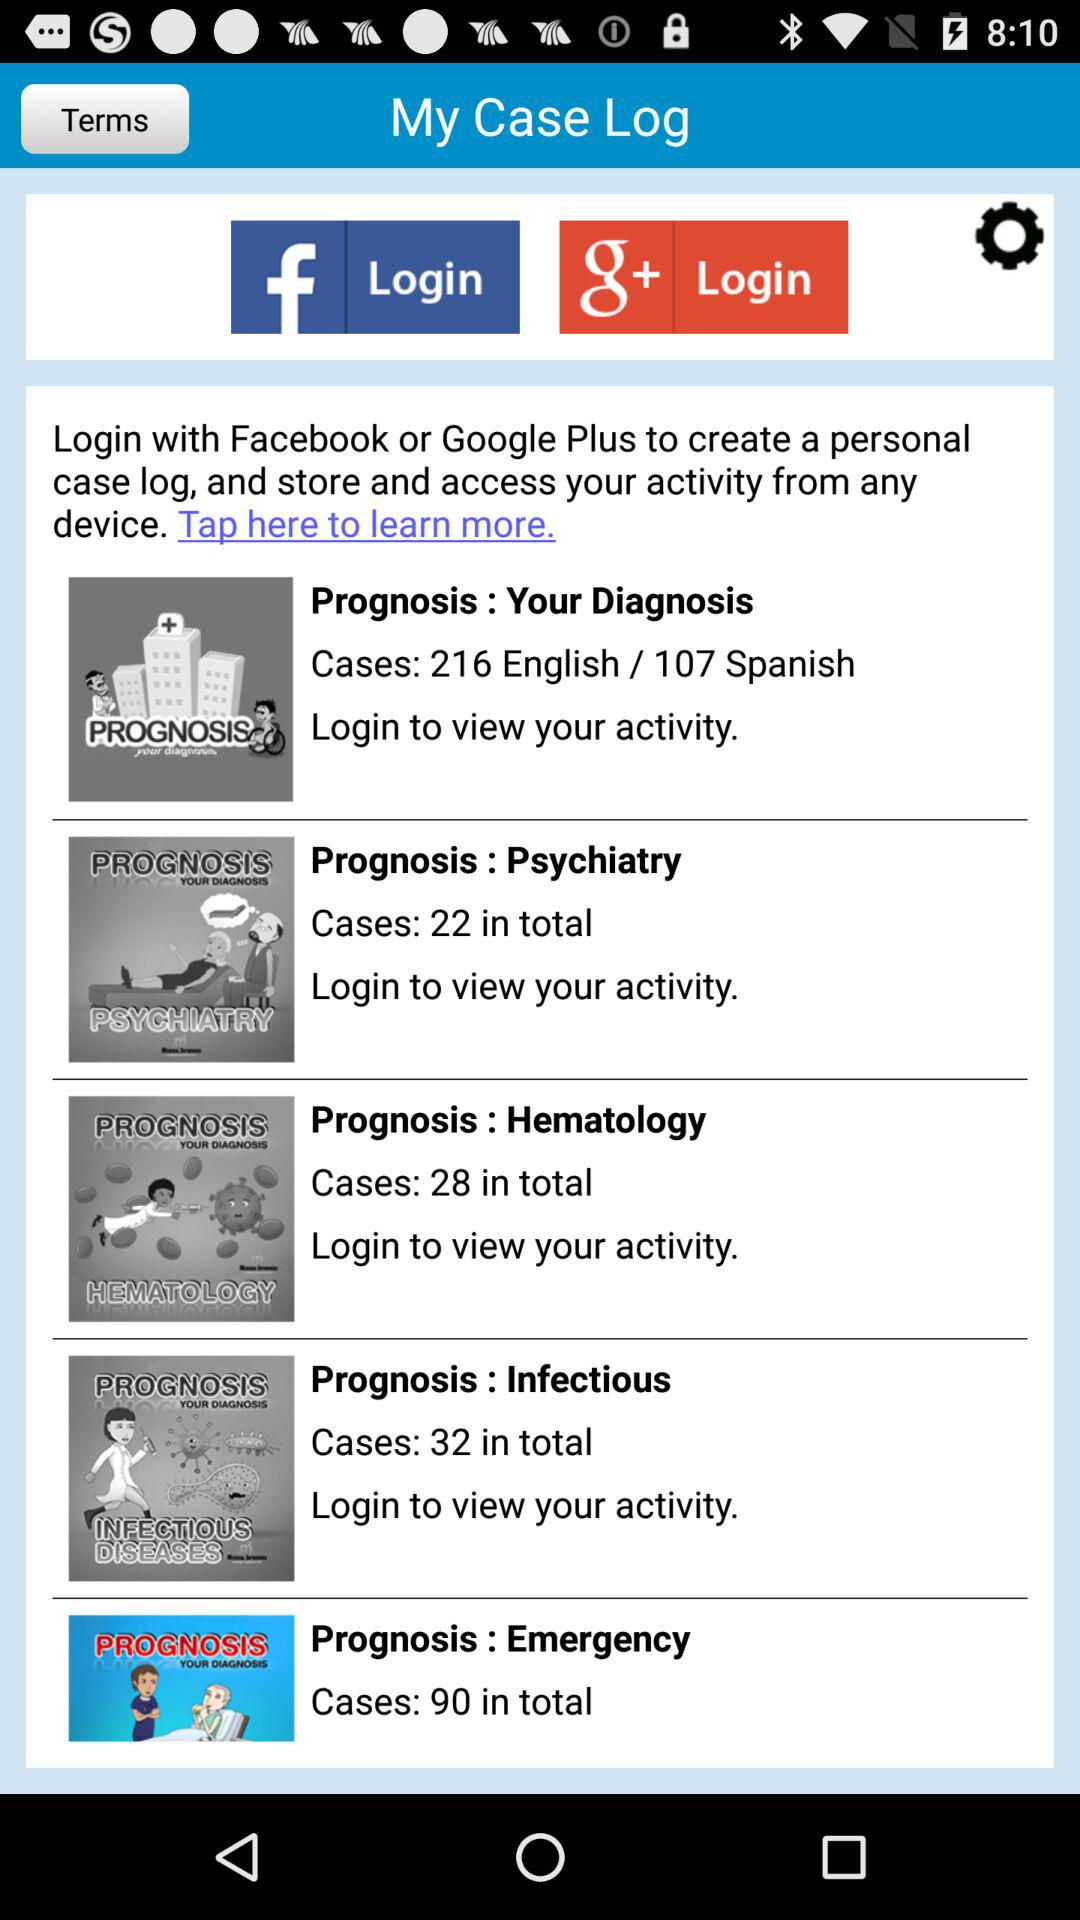How many cases are in "Your Diagnosis" in English? There are 216 cases. 